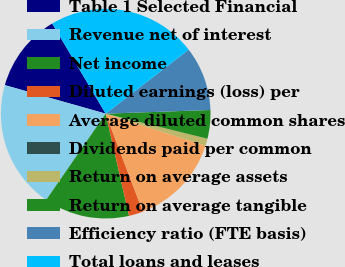Convert chart to OTSL. <chart><loc_0><loc_0><loc_500><loc_500><pie_chart><fcel>Table 1 Selected Financial<fcel>Revenue net of interest<fcel>Net income<fcel>Diluted earnings (loss) per<fcel>Average diluted common shares<fcel>Dividends paid per common<fcel>Return on average assets<fcel>Return on average tangible<fcel>Efficiency ratio (FTE basis)<fcel>Total loans and leases<nl><fcel>12.09%<fcel>19.78%<fcel>13.19%<fcel>2.2%<fcel>14.29%<fcel>0.0%<fcel>1.1%<fcel>4.4%<fcel>9.89%<fcel>23.08%<nl></chart> 